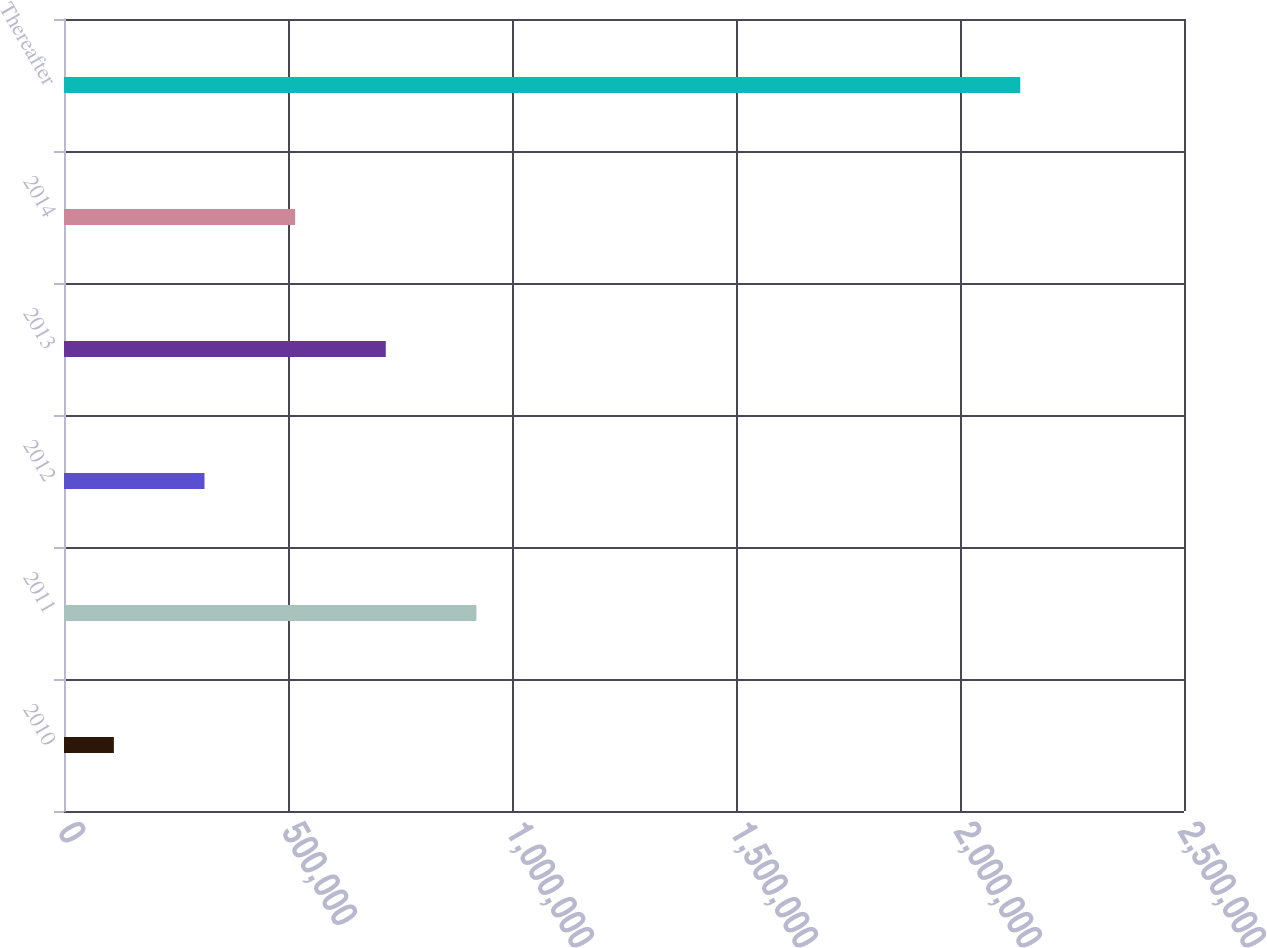Convert chart to OTSL. <chart><loc_0><loc_0><loc_500><loc_500><bar_chart><fcel>2010<fcel>2011<fcel>2012<fcel>2013<fcel>2014<fcel>Thereafter<nl><fcel>111305<fcel>920592<fcel>313627<fcel>718270<fcel>515948<fcel>2.13452e+06<nl></chart> 